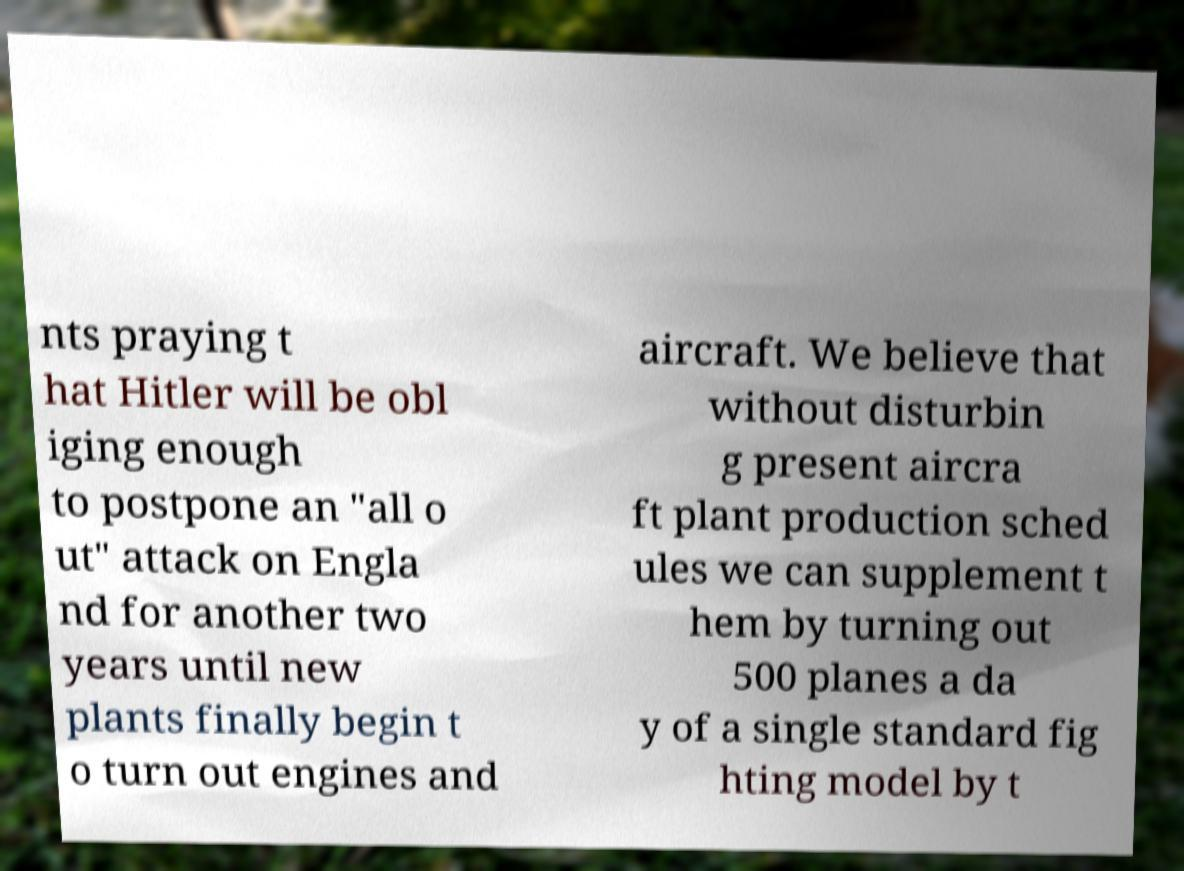For documentation purposes, I need the text within this image transcribed. Could you provide that? nts praying t hat Hitler will be obl iging enough to postpone an "all o ut" attack on Engla nd for another two years until new plants finally begin t o turn out engines and aircraft. We believe that without disturbin g present aircra ft plant production sched ules we can supplement t hem by turning out 500 planes a da y of a single standard fig hting model by t 